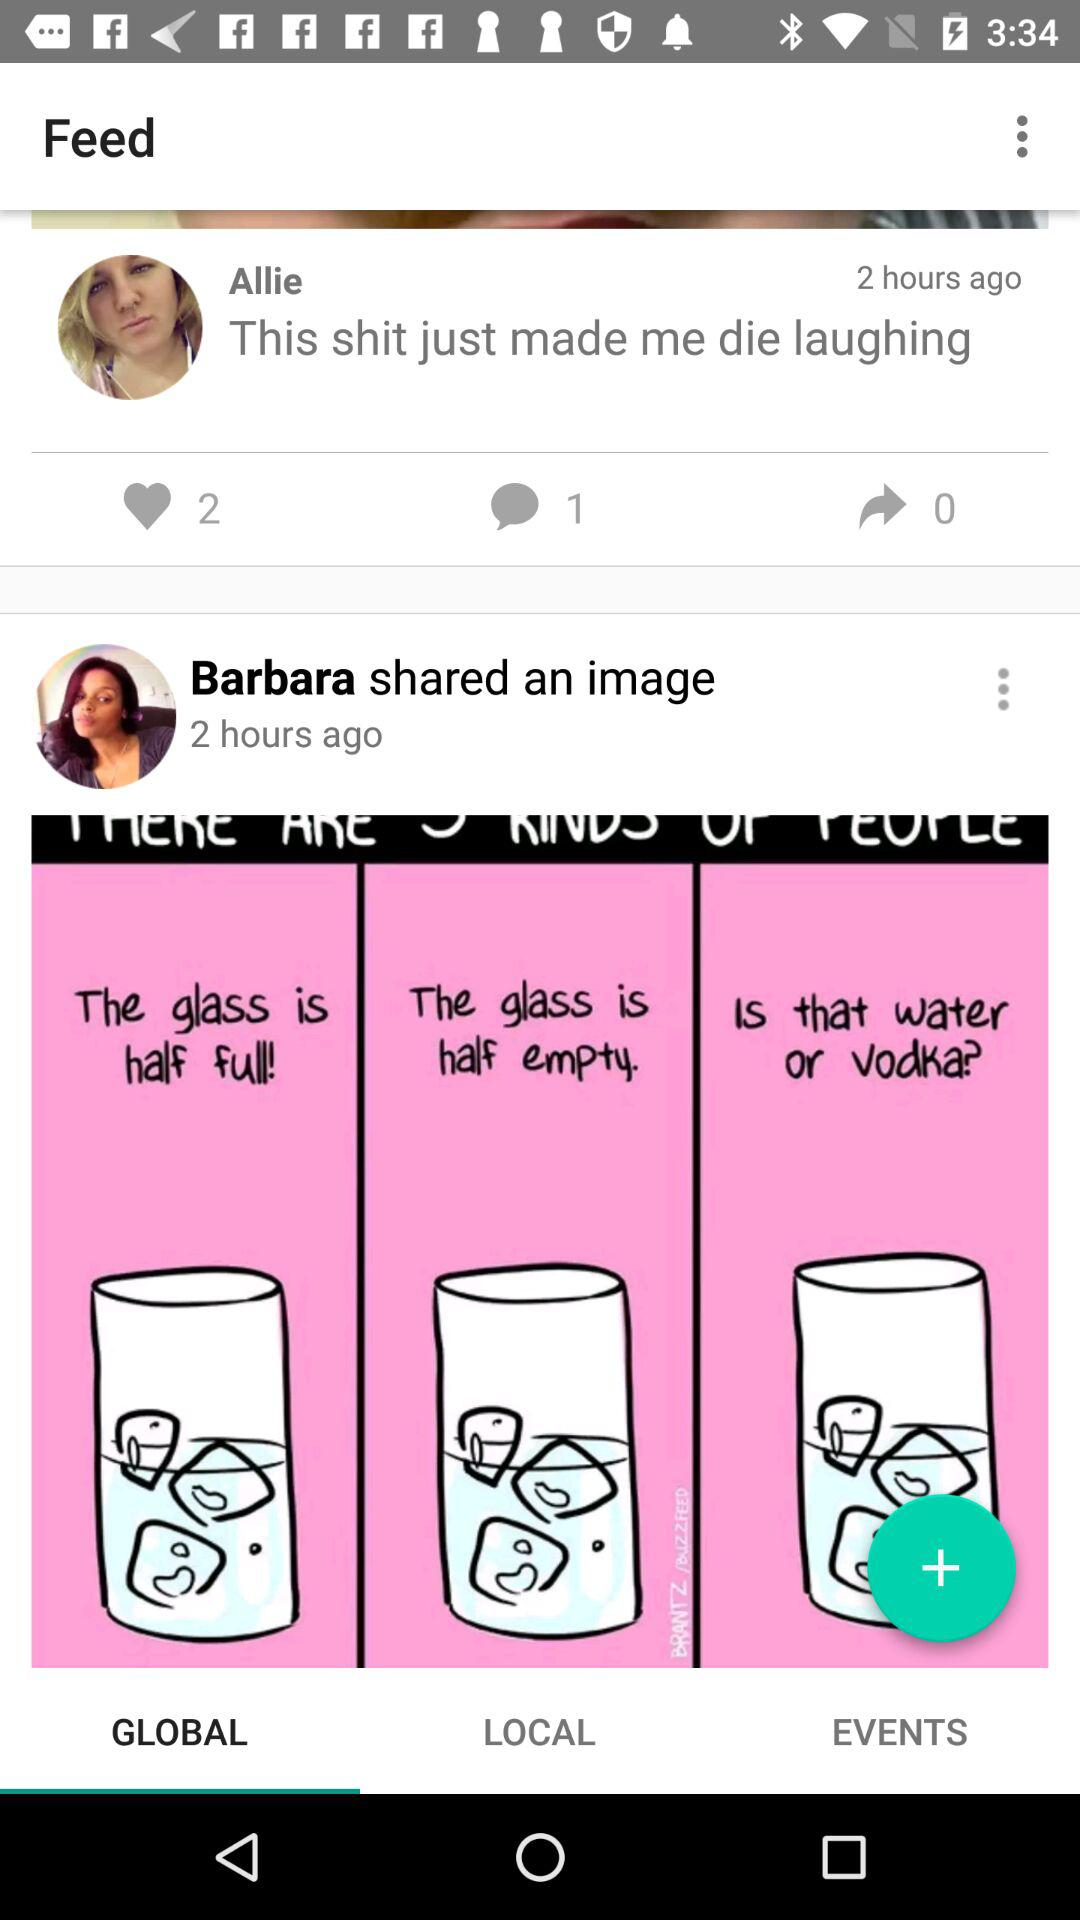Which tab has been selected? The selected tab is "GLOBAL". 